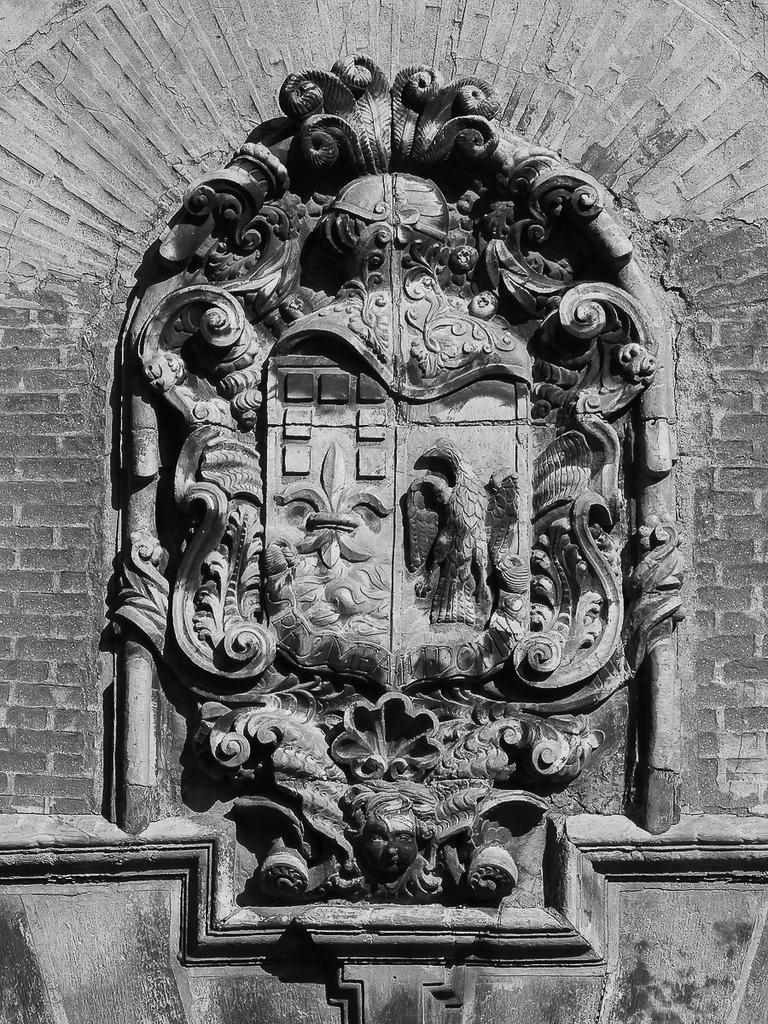What type of sculpture can be seen in the image? There is a floral sculpture in the image. Are there any other sculptures present in the image? Yes, there is a sculpture of a bird on the wall in the image. What type of channel can be seen in the image? There is no channel present in the image. 